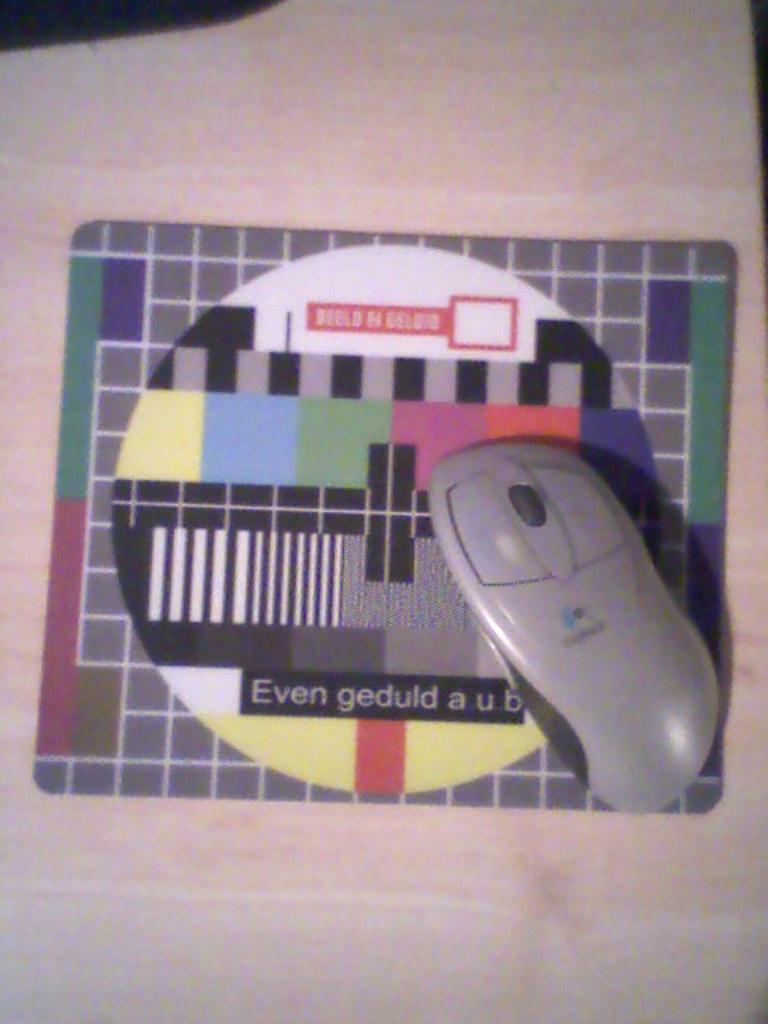In one or two sentences, can you explain what this image depicts? There is a mouse on a mouse pad. 